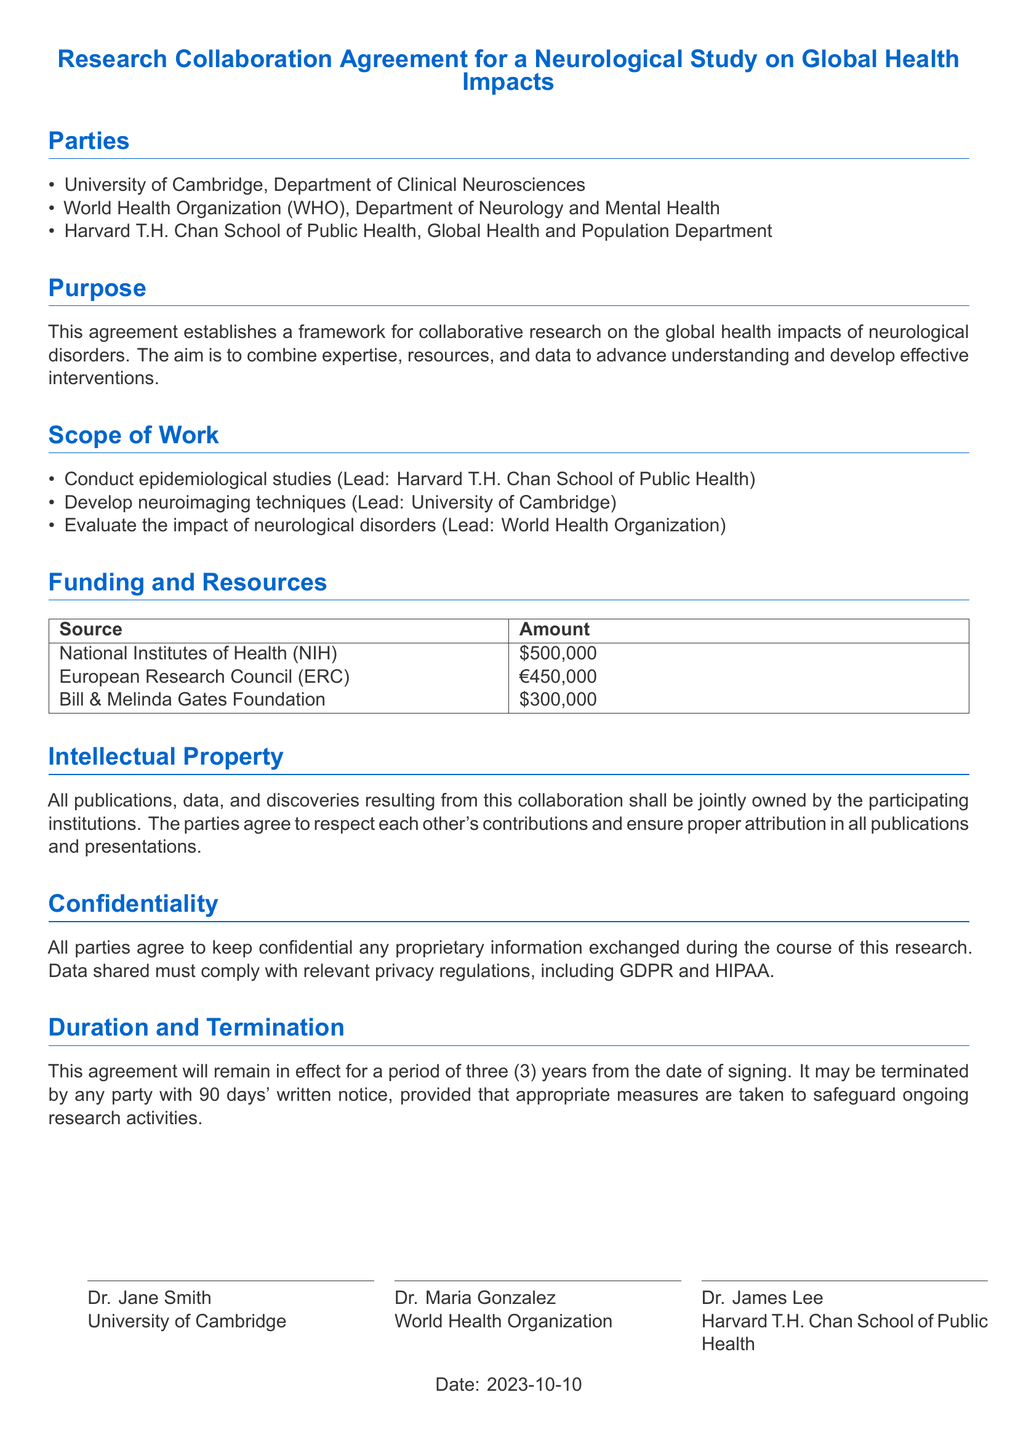What are the names of the collaborating institutions? The document lists the parties involved in the collaboration, which are the University of Cambridge, World Health Organization, and Harvard T.H. Chan School of Public Health.
Answer: University of Cambridge, World Health Organization, Harvard T.H. Chan School of Public Health What is the total funding from the National Institutes of Health? The document explicitly states the funding amount from the National Institutes of Health, which is $500,000.
Answer: $500,000 What is the lead institution for developing neuroimaging techniques? The document indicates that the University of Cambridge is the lead institution for developing neuroimaging techniques.
Answer: University of Cambridge What is the duration of the agreement? The document specifies that the agreement will remain in effect for a period of three years from the date of signing.
Answer: Three years What is required for termination of the agreement? The document states that any party may terminate the agreement with 90 days' written notice while safeguarding ongoing research activities.
Answer: 90 days' written notice What must all parties maintain regarding proprietary information? The document emphasizes that all parties agree to keep confidential any proprietary information exchanged during the research.
Answer: Confidentiality What does the agreement say about intellectual property? The agreement mentions that all publications, data, and discoveries resulting from the collaboration shall be jointly owned by the participating institutions.
Answer: Jointly owned What are two funding sources mentioned? The document lists three funding sources, specifically from NIH and the Bill & Melinda Gates Foundation as two examples.
Answer: NIH, Bill & Melinda Gates Foundation 